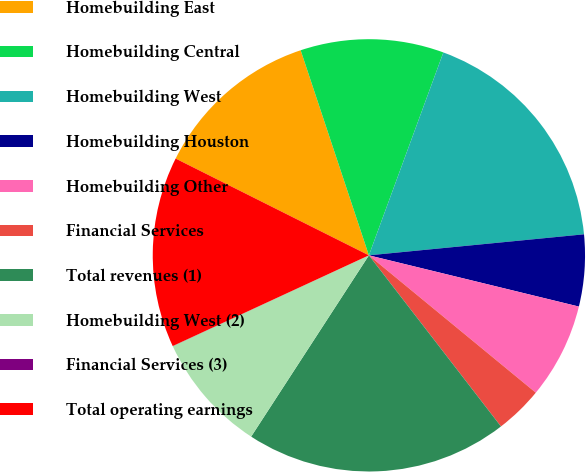Convert chart to OTSL. <chart><loc_0><loc_0><loc_500><loc_500><pie_chart><fcel>Homebuilding East<fcel>Homebuilding Central<fcel>Homebuilding West<fcel>Homebuilding Houston<fcel>Homebuilding Other<fcel>Financial Services<fcel>Total revenues (1)<fcel>Homebuilding West (2)<fcel>Financial Services (3)<fcel>Total operating earnings<nl><fcel>12.5%<fcel>10.71%<fcel>17.85%<fcel>5.36%<fcel>7.15%<fcel>3.58%<fcel>19.63%<fcel>8.93%<fcel>0.01%<fcel>14.28%<nl></chart> 